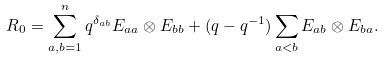<formula> <loc_0><loc_0><loc_500><loc_500>R _ { 0 } = \sum ^ { n } _ { a , b = 1 } q ^ { \delta _ { a b } } E _ { a a } \otimes E _ { b b } + ( q - q ^ { - 1 } ) \sum _ { a < b } E _ { a b } \otimes E _ { b a } .</formula> 